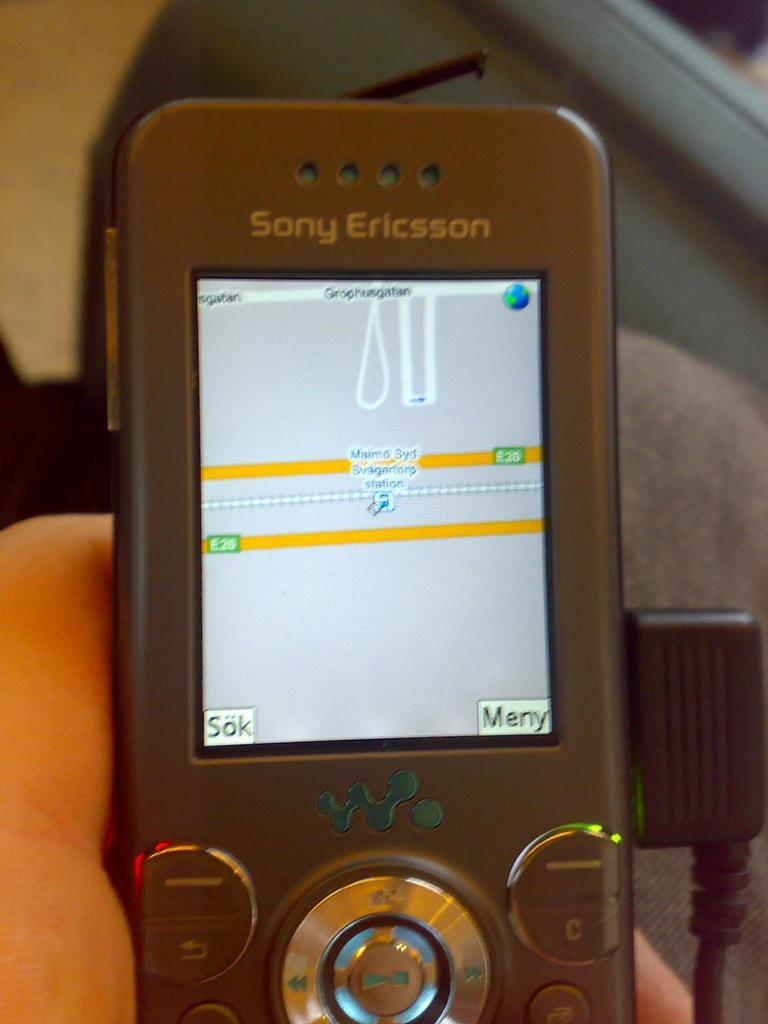<image>
Render a clear and concise summary of the photo. The map application is being used on a Sony Ericsson phone. 